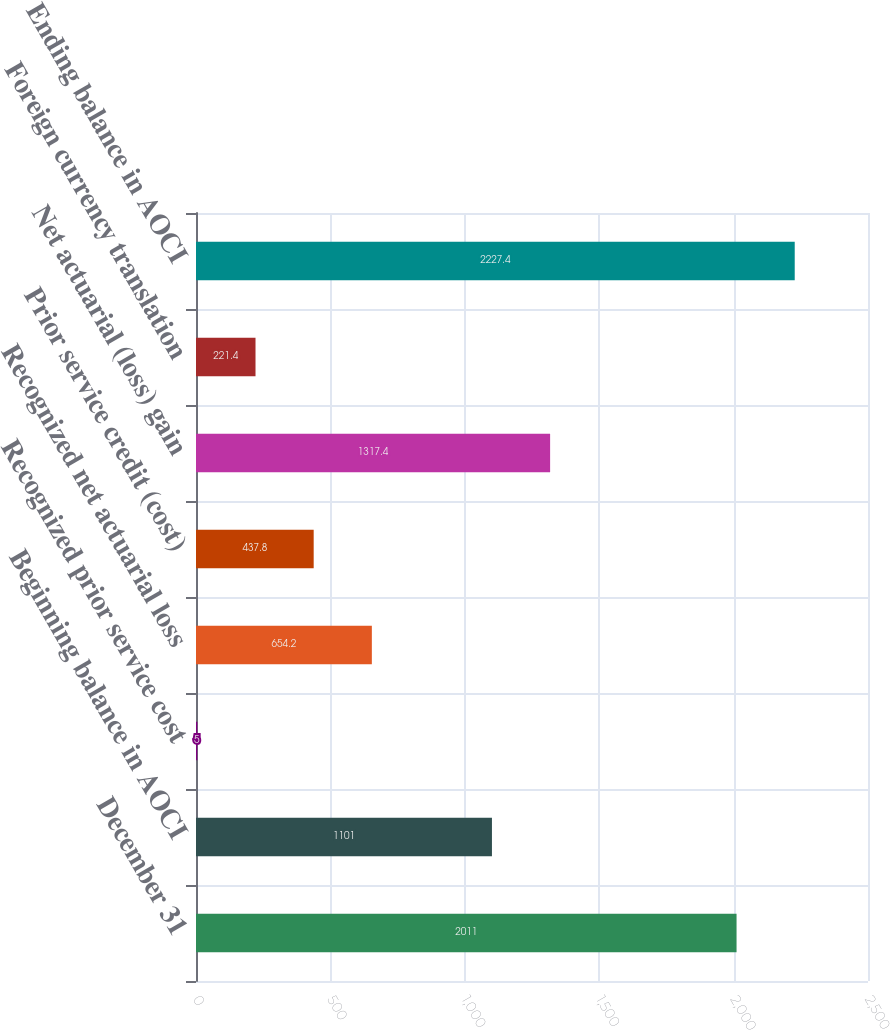<chart> <loc_0><loc_0><loc_500><loc_500><bar_chart><fcel>December 31<fcel>Beginning balance in AOCI<fcel>Recognized prior service cost<fcel>Recognized net actuarial loss<fcel>Prior service credit (cost)<fcel>Net actuarial (loss) gain<fcel>Foreign currency translation<fcel>Ending balance in AOCI<nl><fcel>2011<fcel>1101<fcel>5<fcel>654.2<fcel>437.8<fcel>1317.4<fcel>221.4<fcel>2227.4<nl></chart> 